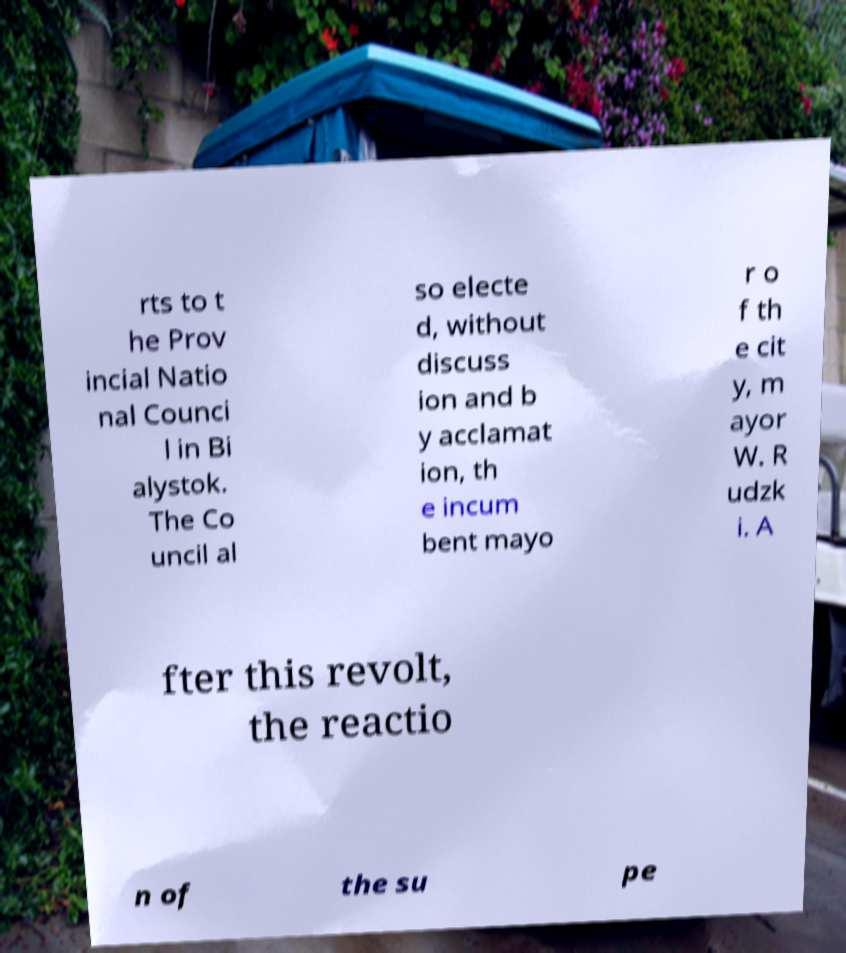There's text embedded in this image that I need extracted. Can you transcribe it verbatim? rts to t he Prov incial Natio nal Counci l in Bi alystok. The Co uncil al so electe d, without discuss ion and b y acclamat ion, th e incum bent mayo r o f th e cit y, m ayor W. R udzk i. A fter this revolt, the reactio n of the su pe 